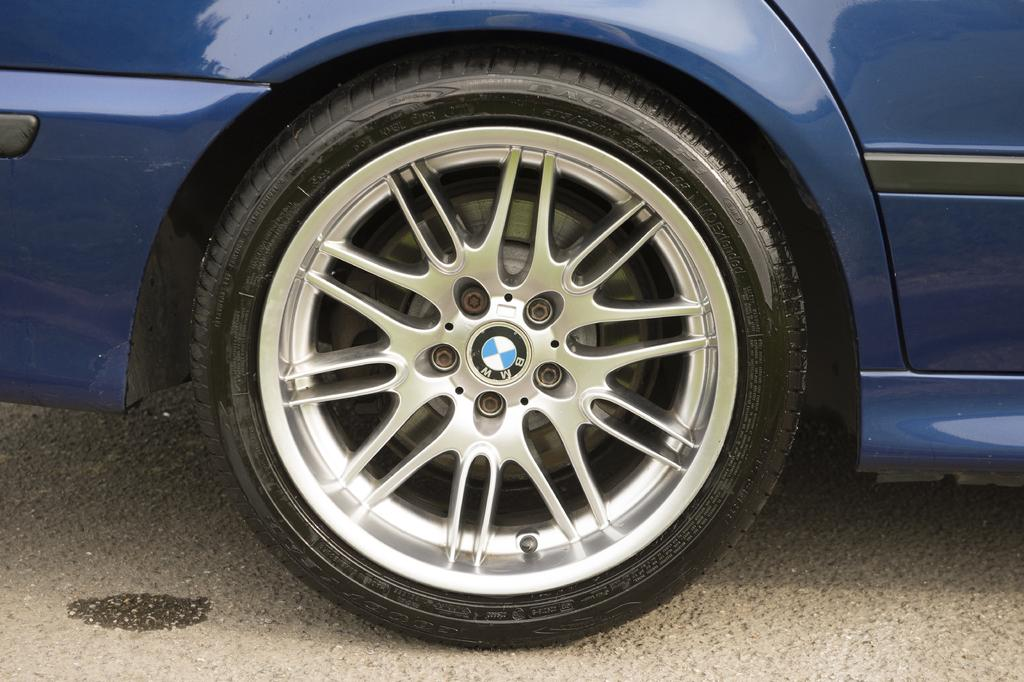What object is present in the image? There is a car tyre in the image. Where is the car tyre located? The car tyre is on the road. What type of wire can be seen wrapped around the car tyre in the image? There is no wire present in the image; it only features a car tyre on the road. 